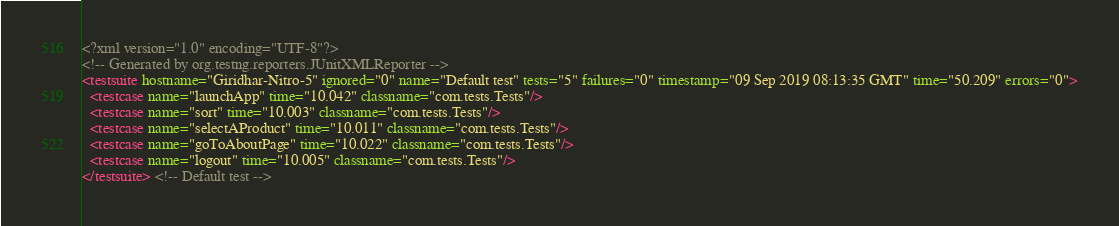<code> <loc_0><loc_0><loc_500><loc_500><_XML_><?xml version="1.0" encoding="UTF-8"?>
<!-- Generated by org.testng.reporters.JUnitXMLReporter -->
<testsuite hostname="Giridhar-Nitro-5" ignored="0" name="Default test" tests="5" failures="0" timestamp="09 Sep 2019 08:13:35 GMT" time="50.209" errors="0">
  <testcase name="launchApp" time="10.042" classname="com.tests.Tests"/>
  <testcase name="sort" time="10.003" classname="com.tests.Tests"/>
  <testcase name="selectAProduct" time="10.011" classname="com.tests.Tests"/>
  <testcase name="goToAboutPage" time="10.022" classname="com.tests.Tests"/>
  <testcase name="logout" time="10.005" classname="com.tests.Tests"/>
</testsuite> <!-- Default test -->
</code> 